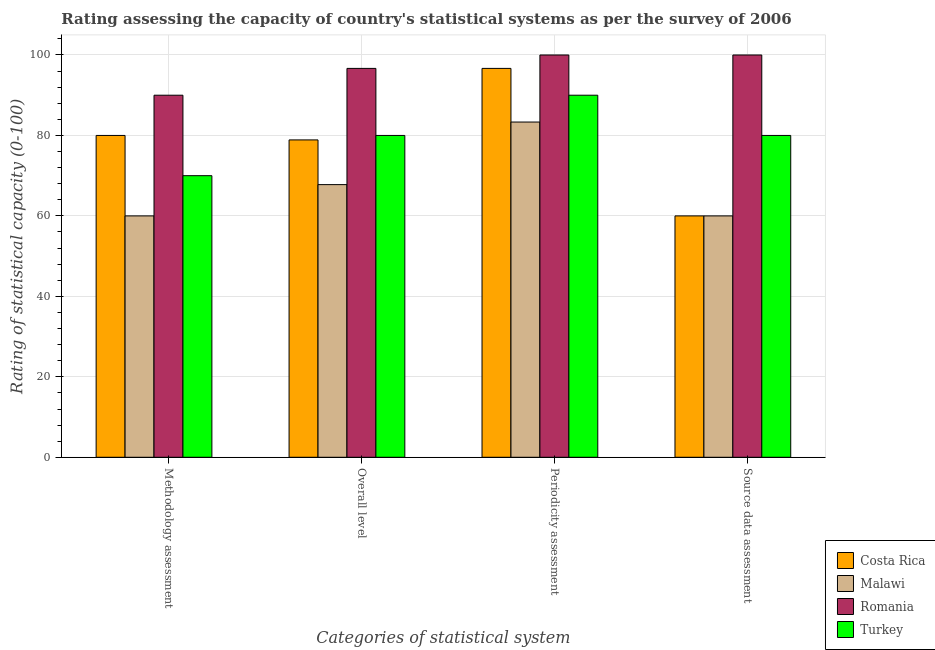How many groups of bars are there?
Ensure brevity in your answer.  4. How many bars are there on the 4th tick from the right?
Keep it short and to the point. 4. What is the label of the 1st group of bars from the left?
Give a very brief answer. Methodology assessment. In which country was the periodicity assessment rating maximum?
Your response must be concise. Romania. In which country was the methodology assessment rating minimum?
Give a very brief answer. Malawi. What is the total methodology assessment rating in the graph?
Your answer should be very brief. 300. What is the difference between the overall level rating in Malawi and that in Turkey?
Your answer should be very brief. -12.22. What is the difference between the overall level rating in Malawi and the periodicity assessment rating in Costa Rica?
Keep it short and to the point. -28.89. What is the average methodology assessment rating per country?
Ensure brevity in your answer.  75. In how many countries, is the periodicity assessment rating greater than 20 ?
Offer a terse response. 4. What is the ratio of the source data assessment rating in Malawi to that in Romania?
Give a very brief answer. 0.6. Is the overall level rating in Malawi less than that in Romania?
Make the answer very short. Yes. Is the difference between the methodology assessment rating in Turkey and Romania greater than the difference between the periodicity assessment rating in Turkey and Romania?
Give a very brief answer. No. What is the difference between the highest and the second highest periodicity assessment rating?
Your response must be concise. 3.33. What is the difference between the highest and the lowest methodology assessment rating?
Make the answer very short. 30. In how many countries, is the overall level rating greater than the average overall level rating taken over all countries?
Provide a succinct answer. 1. What does the 1st bar from the left in Overall level represents?
Offer a very short reply. Costa Rica. Is it the case that in every country, the sum of the methodology assessment rating and overall level rating is greater than the periodicity assessment rating?
Make the answer very short. Yes. How many countries are there in the graph?
Your answer should be very brief. 4. Where does the legend appear in the graph?
Offer a terse response. Bottom right. How are the legend labels stacked?
Your answer should be very brief. Vertical. What is the title of the graph?
Keep it short and to the point. Rating assessing the capacity of country's statistical systems as per the survey of 2006 . What is the label or title of the X-axis?
Your answer should be very brief. Categories of statistical system. What is the label or title of the Y-axis?
Provide a short and direct response. Rating of statistical capacity (0-100). What is the Rating of statistical capacity (0-100) of Costa Rica in Methodology assessment?
Give a very brief answer. 80. What is the Rating of statistical capacity (0-100) of Romania in Methodology assessment?
Ensure brevity in your answer.  90. What is the Rating of statistical capacity (0-100) of Turkey in Methodology assessment?
Offer a terse response. 70. What is the Rating of statistical capacity (0-100) in Costa Rica in Overall level?
Offer a terse response. 78.89. What is the Rating of statistical capacity (0-100) in Malawi in Overall level?
Provide a short and direct response. 67.78. What is the Rating of statistical capacity (0-100) in Romania in Overall level?
Provide a succinct answer. 96.67. What is the Rating of statistical capacity (0-100) of Turkey in Overall level?
Make the answer very short. 80. What is the Rating of statistical capacity (0-100) of Costa Rica in Periodicity assessment?
Provide a short and direct response. 96.67. What is the Rating of statistical capacity (0-100) of Malawi in Periodicity assessment?
Give a very brief answer. 83.33. What is the Rating of statistical capacity (0-100) in Romania in Periodicity assessment?
Offer a very short reply. 100. What is the Rating of statistical capacity (0-100) of Turkey in Periodicity assessment?
Make the answer very short. 90. What is the Rating of statistical capacity (0-100) of Malawi in Source data assessment?
Offer a very short reply. 60. Across all Categories of statistical system, what is the maximum Rating of statistical capacity (0-100) in Costa Rica?
Your answer should be compact. 96.67. Across all Categories of statistical system, what is the maximum Rating of statistical capacity (0-100) of Malawi?
Your answer should be compact. 83.33. Across all Categories of statistical system, what is the minimum Rating of statistical capacity (0-100) of Costa Rica?
Give a very brief answer. 60. What is the total Rating of statistical capacity (0-100) of Costa Rica in the graph?
Your response must be concise. 315.56. What is the total Rating of statistical capacity (0-100) of Malawi in the graph?
Give a very brief answer. 271.11. What is the total Rating of statistical capacity (0-100) in Romania in the graph?
Keep it short and to the point. 386.67. What is the total Rating of statistical capacity (0-100) of Turkey in the graph?
Offer a terse response. 320. What is the difference between the Rating of statistical capacity (0-100) of Costa Rica in Methodology assessment and that in Overall level?
Offer a very short reply. 1.11. What is the difference between the Rating of statistical capacity (0-100) of Malawi in Methodology assessment and that in Overall level?
Your answer should be very brief. -7.78. What is the difference between the Rating of statistical capacity (0-100) in Romania in Methodology assessment and that in Overall level?
Your answer should be compact. -6.67. What is the difference between the Rating of statistical capacity (0-100) of Turkey in Methodology assessment and that in Overall level?
Offer a very short reply. -10. What is the difference between the Rating of statistical capacity (0-100) in Costa Rica in Methodology assessment and that in Periodicity assessment?
Provide a short and direct response. -16.67. What is the difference between the Rating of statistical capacity (0-100) in Malawi in Methodology assessment and that in Periodicity assessment?
Ensure brevity in your answer.  -23.33. What is the difference between the Rating of statistical capacity (0-100) of Romania in Methodology assessment and that in Periodicity assessment?
Your response must be concise. -10. What is the difference between the Rating of statistical capacity (0-100) in Malawi in Methodology assessment and that in Source data assessment?
Provide a short and direct response. 0. What is the difference between the Rating of statistical capacity (0-100) in Romania in Methodology assessment and that in Source data assessment?
Your answer should be very brief. -10. What is the difference between the Rating of statistical capacity (0-100) of Turkey in Methodology assessment and that in Source data assessment?
Give a very brief answer. -10. What is the difference between the Rating of statistical capacity (0-100) in Costa Rica in Overall level and that in Periodicity assessment?
Offer a terse response. -17.78. What is the difference between the Rating of statistical capacity (0-100) of Malawi in Overall level and that in Periodicity assessment?
Your response must be concise. -15.56. What is the difference between the Rating of statistical capacity (0-100) of Romania in Overall level and that in Periodicity assessment?
Your answer should be compact. -3.33. What is the difference between the Rating of statistical capacity (0-100) in Costa Rica in Overall level and that in Source data assessment?
Provide a succinct answer. 18.89. What is the difference between the Rating of statistical capacity (0-100) in Malawi in Overall level and that in Source data assessment?
Offer a very short reply. 7.78. What is the difference between the Rating of statistical capacity (0-100) of Turkey in Overall level and that in Source data assessment?
Your answer should be compact. 0. What is the difference between the Rating of statistical capacity (0-100) of Costa Rica in Periodicity assessment and that in Source data assessment?
Provide a succinct answer. 36.67. What is the difference between the Rating of statistical capacity (0-100) of Malawi in Periodicity assessment and that in Source data assessment?
Offer a very short reply. 23.33. What is the difference between the Rating of statistical capacity (0-100) in Romania in Periodicity assessment and that in Source data assessment?
Provide a succinct answer. 0. What is the difference between the Rating of statistical capacity (0-100) in Costa Rica in Methodology assessment and the Rating of statistical capacity (0-100) in Malawi in Overall level?
Provide a short and direct response. 12.22. What is the difference between the Rating of statistical capacity (0-100) of Costa Rica in Methodology assessment and the Rating of statistical capacity (0-100) of Romania in Overall level?
Provide a succinct answer. -16.67. What is the difference between the Rating of statistical capacity (0-100) of Costa Rica in Methodology assessment and the Rating of statistical capacity (0-100) of Turkey in Overall level?
Provide a short and direct response. 0. What is the difference between the Rating of statistical capacity (0-100) of Malawi in Methodology assessment and the Rating of statistical capacity (0-100) of Romania in Overall level?
Provide a succinct answer. -36.67. What is the difference between the Rating of statistical capacity (0-100) of Costa Rica in Methodology assessment and the Rating of statistical capacity (0-100) of Malawi in Periodicity assessment?
Keep it short and to the point. -3.33. What is the difference between the Rating of statistical capacity (0-100) in Costa Rica in Methodology assessment and the Rating of statistical capacity (0-100) in Romania in Periodicity assessment?
Make the answer very short. -20. What is the difference between the Rating of statistical capacity (0-100) of Costa Rica in Methodology assessment and the Rating of statistical capacity (0-100) of Turkey in Periodicity assessment?
Your answer should be compact. -10. What is the difference between the Rating of statistical capacity (0-100) of Malawi in Methodology assessment and the Rating of statistical capacity (0-100) of Romania in Periodicity assessment?
Provide a short and direct response. -40. What is the difference between the Rating of statistical capacity (0-100) of Malawi in Methodology assessment and the Rating of statistical capacity (0-100) of Turkey in Periodicity assessment?
Your response must be concise. -30. What is the difference between the Rating of statistical capacity (0-100) in Costa Rica in Methodology assessment and the Rating of statistical capacity (0-100) in Malawi in Source data assessment?
Your response must be concise. 20. What is the difference between the Rating of statistical capacity (0-100) of Costa Rica in Methodology assessment and the Rating of statistical capacity (0-100) of Turkey in Source data assessment?
Offer a terse response. 0. What is the difference between the Rating of statistical capacity (0-100) in Malawi in Methodology assessment and the Rating of statistical capacity (0-100) in Romania in Source data assessment?
Offer a very short reply. -40. What is the difference between the Rating of statistical capacity (0-100) in Romania in Methodology assessment and the Rating of statistical capacity (0-100) in Turkey in Source data assessment?
Give a very brief answer. 10. What is the difference between the Rating of statistical capacity (0-100) of Costa Rica in Overall level and the Rating of statistical capacity (0-100) of Malawi in Periodicity assessment?
Your response must be concise. -4.44. What is the difference between the Rating of statistical capacity (0-100) in Costa Rica in Overall level and the Rating of statistical capacity (0-100) in Romania in Periodicity assessment?
Your answer should be compact. -21.11. What is the difference between the Rating of statistical capacity (0-100) of Costa Rica in Overall level and the Rating of statistical capacity (0-100) of Turkey in Periodicity assessment?
Provide a short and direct response. -11.11. What is the difference between the Rating of statistical capacity (0-100) in Malawi in Overall level and the Rating of statistical capacity (0-100) in Romania in Periodicity assessment?
Offer a very short reply. -32.22. What is the difference between the Rating of statistical capacity (0-100) in Malawi in Overall level and the Rating of statistical capacity (0-100) in Turkey in Periodicity assessment?
Offer a terse response. -22.22. What is the difference between the Rating of statistical capacity (0-100) of Costa Rica in Overall level and the Rating of statistical capacity (0-100) of Malawi in Source data assessment?
Ensure brevity in your answer.  18.89. What is the difference between the Rating of statistical capacity (0-100) in Costa Rica in Overall level and the Rating of statistical capacity (0-100) in Romania in Source data assessment?
Give a very brief answer. -21.11. What is the difference between the Rating of statistical capacity (0-100) of Costa Rica in Overall level and the Rating of statistical capacity (0-100) of Turkey in Source data assessment?
Offer a terse response. -1.11. What is the difference between the Rating of statistical capacity (0-100) of Malawi in Overall level and the Rating of statistical capacity (0-100) of Romania in Source data assessment?
Provide a short and direct response. -32.22. What is the difference between the Rating of statistical capacity (0-100) of Malawi in Overall level and the Rating of statistical capacity (0-100) of Turkey in Source data assessment?
Ensure brevity in your answer.  -12.22. What is the difference between the Rating of statistical capacity (0-100) in Romania in Overall level and the Rating of statistical capacity (0-100) in Turkey in Source data assessment?
Give a very brief answer. 16.67. What is the difference between the Rating of statistical capacity (0-100) of Costa Rica in Periodicity assessment and the Rating of statistical capacity (0-100) of Malawi in Source data assessment?
Your answer should be very brief. 36.67. What is the difference between the Rating of statistical capacity (0-100) in Costa Rica in Periodicity assessment and the Rating of statistical capacity (0-100) in Turkey in Source data assessment?
Your answer should be compact. 16.67. What is the difference between the Rating of statistical capacity (0-100) in Malawi in Periodicity assessment and the Rating of statistical capacity (0-100) in Romania in Source data assessment?
Keep it short and to the point. -16.67. What is the difference between the Rating of statistical capacity (0-100) of Malawi in Periodicity assessment and the Rating of statistical capacity (0-100) of Turkey in Source data assessment?
Keep it short and to the point. 3.33. What is the average Rating of statistical capacity (0-100) of Costa Rica per Categories of statistical system?
Make the answer very short. 78.89. What is the average Rating of statistical capacity (0-100) in Malawi per Categories of statistical system?
Keep it short and to the point. 67.78. What is the average Rating of statistical capacity (0-100) in Romania per Categories of statistical system?
Give a very brief answer. 96.67. What is the difference between the Rating of statistical capacity (0-100) of Costa Rica and Rating of statistical capacity (0-100) of Malawi in Methodology assessment?
Your answer should be compact. 20. What is the difference between the Rating of statistical capacity (0-100) in Costa Rica and Rating of statistical capacity (0-100) in Romania in Methodology assessment?
Ensure brevity in your answer.  -10. What is the difference between the Rating of statistical capacity (0-100) of Malawi and Rating of statistical capacity (0-100) of Turkey in Methodology assessment?
Keep it short and to the point. -10. What is the difference between the Rating of statistical capacity (0-100) in Romania and Rating of statistical capacity (0-100) in Turkey in Methodology assessment?
Offer a very short reply. 20. What is the difference between the Rating of statistical capacity (0-100) of Costa Rica and Rating of statistical capacity (0-100) of Malawi in Overall level?
Offer a terse response. 11.11. What is the difference between the Rating of statistical capacity (0-100) in Costa Rica and Rating of statistical capacity (0-100) in Romania in Overall level?
Offer a very short reply. -17.78. What is the difference between the Rating of statistical capacity (0-100) in Costa Rica and Rating of statistical capacity (0-100) in Turkey in Overall level?
Offer a terse response. -1.11. What is the difference between the Rating of statistical capacity (0-100) of Malawi and Rating of statistical capacity (0-100) of Romania in Overall level?
Your answer should be compact. -28.89. What is the difference between the Rating of statistical capacity (0-100) of Malawi and Rating of statistical capacity (0-100) of Turkey in Overall level?
Ensure brevity in your answer.  -12.22. What is the difference between the Rating of statistical capacity (0-100) in Romania and Rating of statistical capacity (0-100) in Turkey in Overall level?
Provide a short and direct response. 16.67. What is the difference between the Rating of statistical capacity (0-100) in Costa Rica and Rating of statistical capacity (0-100) in Malawi in Periodicity assessment?
Keep it short and to the point. 13.33. What is the difference between the Rating of statistical capacity (0-100) in Costa Rica and Rating of statistical capacity (0-100) in Romania in Periodicity assessment?
Ensure brevity in your answer.  -3.33. What is the difference between the Rating of statistical capacity (0-100) of Malawi and Rating of statistical capacity (0-100) of Romania in Periodicity assessment?
Provide a succinct answer. -16.67. What is the difference between the Rating of statistical capacity (0-100) of Malawi and Rating of statistical capacity (0-100) of Turkey in Periodicity assessment?
Provide a short and direct response. -6.67. What is the difference between the Rating of statistical capacity (0-100) of Costa Rica and Rating of statistical capacity (0-100) of Turkey in Source data assessment?
Offer a very short reply. -20. What is the difference between the Rating of statistical capacity (0-100) of Malawi and Rating of statistical capacity (0-100) of Turkey in Source data assessment?
Keep it short and to the point. -20. What is the ratio of the Rating of statistical capacity (0-100) in Costa Rica in Methodology assessment to that in Overall level?
Offer a terse response. 1.01. What is the ratio of the Rating of statistical capacity (0-100) of Malawi in Methodology assessment to that in Overall level?
Offer a very short reply. 0.89. What is the ratio of the Rating of statistical capacity (0-100) of Costa Rica in Methodology assessment to that in Periodicity assessment?
Your answer should be compact. 0.83. What is the ratio of the Rating of statistical capacity (0-100) in Malawi in Methodology assessment to that in Periodicity assessment?
Offer a terse response. 0.72. What is the ratio of the Rating of statistical capacity (0-100) of Turkey in Methodology assessment to that in Periodicity assessment?
Your response must be concise. 0.78. What is the ratio of the Rating of statistical capacity (0-100) of Costa Rica in Methodology assessment to that in Source data assessment?
Provide a short and direct response. 1.33. What is the ratio of the Rating of statistical capacity (0-100) in Malawi in Methodology assessment to that in Source data assessment?
Offer a terse response. 1. What is the ratio of the Rating of statistical capacity (0-100) of Romania in Methodology assessment to that in Source data assessment?
Give a very brief answer. 0.9. What is the ratio of the Rating of statistical capacity (0-100) in Turkey in Methodology assessment to that in Source data assessment?
Offer a terse response. 0.88. What is the ratio of the Rating of statistical capacity (0-100) in Costa Rica in Overall level to that in Periodicity assessment?
Your response must be concise. 0.82. What is the ratio of the Rating of statistical capacity (0-100) in Malawi in Overall level to that in Periodicity assessment?
Your response must be concise. 0.81. What is the ratio of the Rating of statistical capacity (0-100) in Romania in Overall level to that in Periodicity assessment?
Offer a terse response. 0.97. What is the ratio of the Rating of statistical capacity (0-100) in Turkey in Overall level to that in Periodicity assessment?
Provide a succinct answer. 0.89. What is the ratio of the Rating of statistical capacity (0-100) in Costa Rica in Overall level to that in Source data assessment?
Ensure brevity in your answer.  1.31. What is the ratio of the Rating of statistical capacity (0-100) in Malawi in Overall level to that in Source data assessment?
Make the answer very short. 1.13. What is the ratio of the Rating of statistical capacity (0-100) of Romania in Overall level to that in Source data assessment?
Your answer should be very brief. 0.97. What is the ratio of the Rating of statistical capacity (0-100) in Turkey in Overall level to that in Source data assessment?
Your answer should be very brief. 1. What is the ratio of the Rating of statistical capacity (0-100) of Costa Rica in Periodicity assessment to that in Source data assessment?
Provide a succinct answer. 1.61. What is the ratio of the Rating of statistical capacity (0-100) of Malawi in Periodicity assessment to that in Source data assessment?
Provide a short and direct response. 1.39. What is the ratio of the Rating of statistical capacity (0-100) of Romania in Periodicity assessment to that in Source data assessment?
Make the answer very short. 1. What is the ratio of the Rating of statistical capacity (0-100) in Turkey in Periodicity assessment to that in Source data assessment?
Your response must be concise. 1.12. What is the difference between the highest and the second highest Rating of statistical capacity (0-100) of Costa Rica?
Provide a short and direct response. 16.67. What is the difference between the highest and the second highest Rating of statistical capacity (0-100) in Malawi?
Offer a terse response. 15.56. What is the difference between the highest and the second highest Rating of statistical capacity (0-100) of Turkey?
Provide a short and direct response. 10. What is the difference between the highest and the lowest Rating of statistical capacity (0-100) of Costa Rica?
Your response must be concise. 36.67. What is the difference between the highest and the lowest Rating of statistical capacity (0-100) in Malawi?
Give a very brief answer. 23.33. What is the difference between the highest and the lowest Rating of statistical capacity (0-100) of Romania?
Give a very brief answer. 10. What is the difference between the highest and the lowest Rating of statistical capacity (0-100) in Turkey?
Keep it short and to the point. 20. 